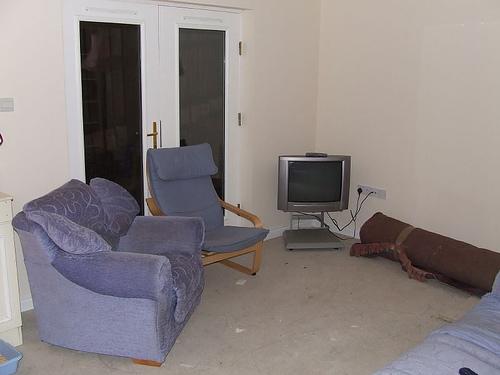Is there a bed in the room?
Be succinct. No. Why is the TV on the floor?
Write a very short answer. No stand. Are stains on the floor?
Give a very brief answer. Yes. How many chairs are there?
Be succinct. 2. How many doors are in this picture?
Answer briefly. 2. 